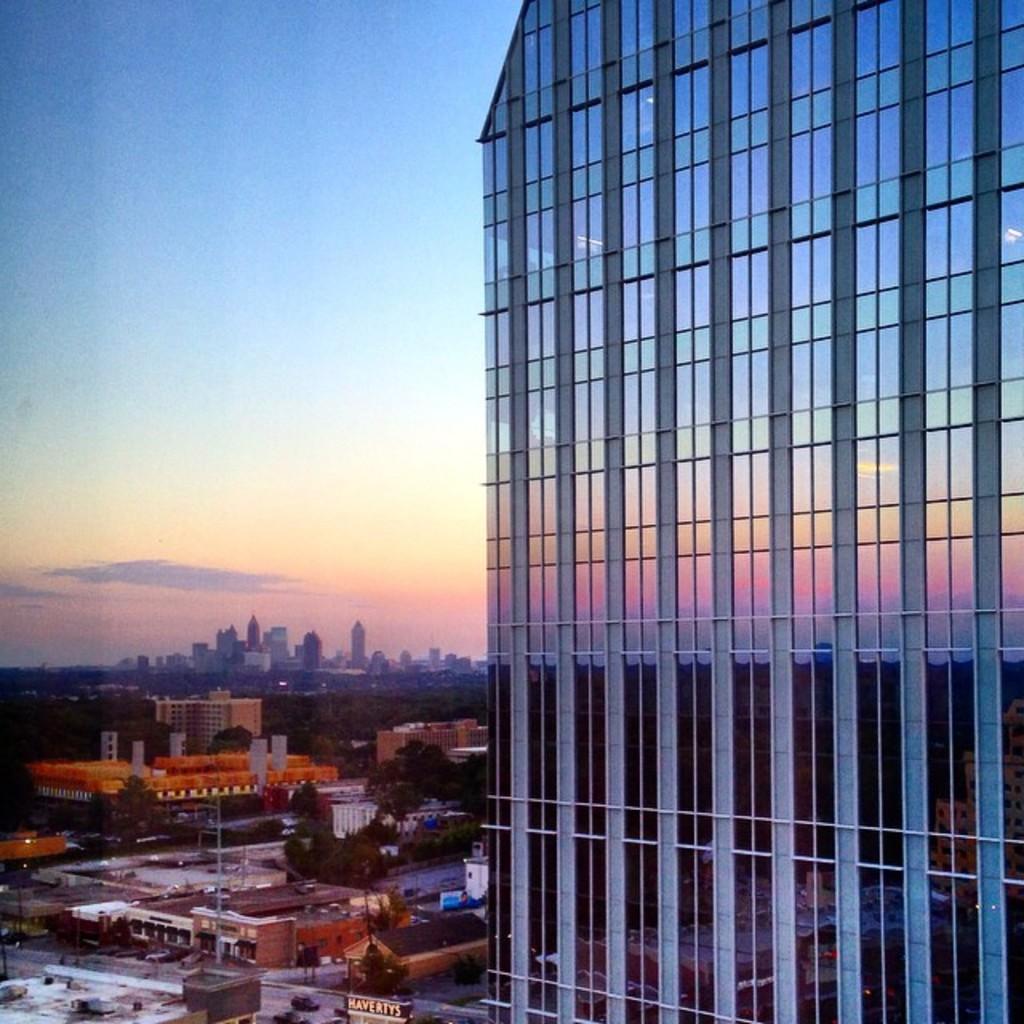In one or two sentences, can you explain what this image depicts? In this picture, we can see buildings, houses, trees, pole, skyscrapers and a sky. 